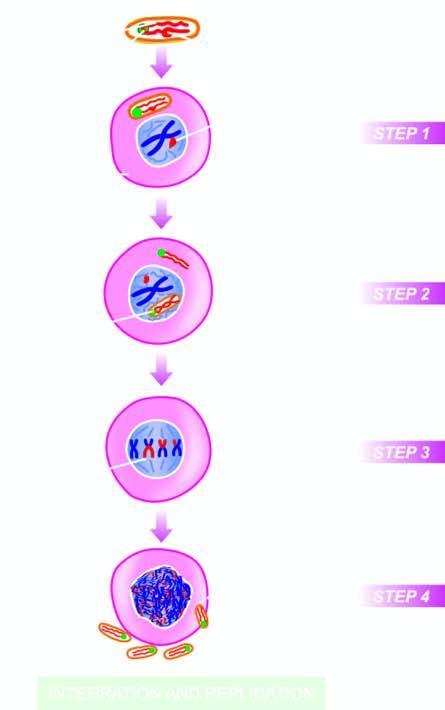what are viral rna genome as well as reverse transcriptase released into?
Answer the question using a single word or phrase. The cytosol 